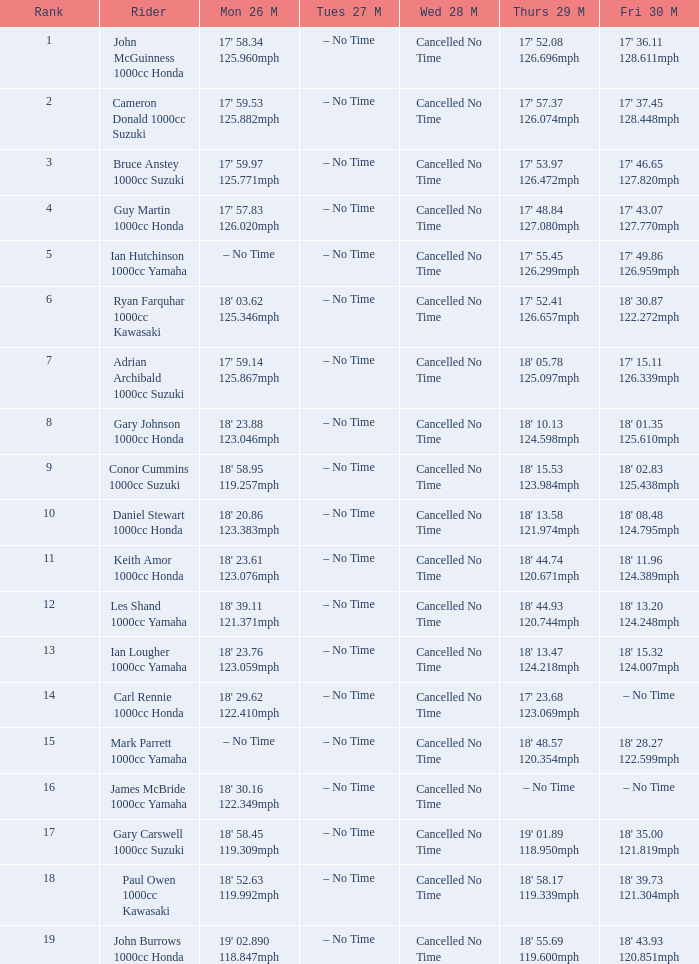What is the numbr for fri may 30 and mon may 26 is 19' 02.890 118.847mph? 18' 43.93 120.851mph. 